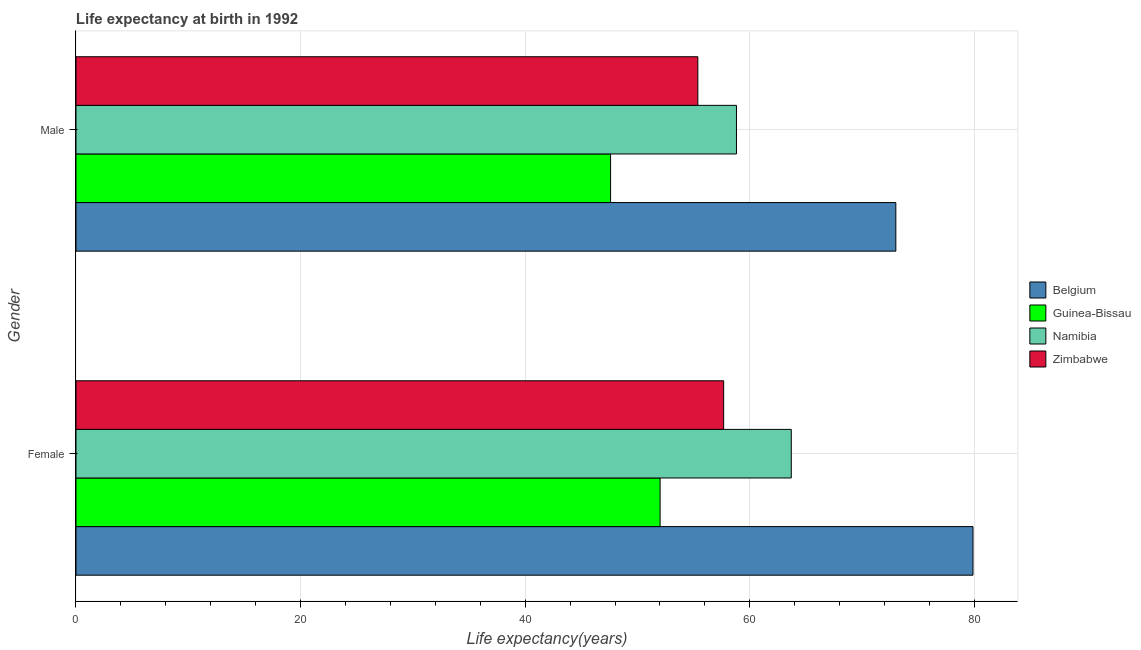How many groups of bars are there?
Your response must be concise. 2. Are the number of bars per tick equal to the number of legend labels?
Keep it short and to the point. Yes. Are the number of bars on each tick of the Y-axis equal?
Your response must be concise. Yes. How many bars are there on the 1st tick from the top?
Provide a succinct answer. 4. What is the life expectancy(female) in Belgium?
Give a very brief answer. 79.87. Across all countries, what is the maximum life expectancy(female)?
Your answer should be compact. 79.87. Across all countries, what is the minimum life expectancy(male)?
Offer a very short reply. 47.6. In which country was the life expectancy(female) minimum?
Ensure brevity in your answer.  Guinea-Bissau. What is the total life expectancy(female) in the graph?
Your answer should be very brief. 253.24. What is the difference between the life expectancy(female) in Belgium and that in Guinea-Bissau?
Your response must be concise. 27.86. What is the difference between the life expectancy(female) in Belgium and the life expectancy(male) in Zimbabwe?
Keep it short and to the point. 24.5. What is the average life expectancy(male) per country?
Provide a succinct answer. 58.7. What is the difference between the life expectancy(female) and life expectancy(male) in Namibia?
Give a very brief answer. 4.88. In how many countries, is the life expectancy(female) greater than 72 years?
Offer a very short reply. 1. What is the ratio of the life expectancy(male) in Guinea-Bissau to that in Belgium?
Provide a succinct answer. 0.65. What does the 3rd bar from the top in Male represents?
Your response must be concise. Guinea-Bissau. What does the 4th bar from the bottom in Male represents?
Your answer should be very brief. Zimbabwe. How many bars are there?
Provide a short and direct response. 8. What is the difference between two consecutive major ticks on the X-axis?
Ensure brevity in your answer.  20. How many legend labels are there?
Your answer should be compact. 4. What is the title of the graph?
Offer a terse response. Life expectancy at birth in 1992. What is the label or title of the X-axis?
Give a very brief answer. Life expectancy(years). What is the Life expectancy(years) in Belgium in Female?
Your answer should be compact. 79.87. What is the Life expectancy(years) of Guinea-Bissau in Female?
Your answer should be very brief. 52.01. What is the Life expectancy(years) in Namibia in Female?
Offer a terse response. 63.69. What is the Life expectancy(years) of Zimbabwe in Female?
Offer a very short reply. 57.67. What is the Life expectancy(years) in Guinea-Bissau in Male?
Offer a terse response. 47.6. What is the Life expectancy(years) in Namibia in Male?
Provide a short and direct response. 58.81. What is the Life expectancy(years) of Zimbabwe in Male?
Your answer should be compact. 55.37. Across all Gender, what is the maximum Life expectancy(years) in Belgium?
Provide a succinct answer. 79.87. Across all Gender, what is the maximum Life expectancy(years) in Guinea-Bissau?
Your answer should be compact. 52.01. Across all Gender, what is the maximum Life expectancy(years) in Namibia?
Provide a succinct answer. 63.69. Across all Gender, what is the maximum Life expectancy(years) in Zimbabwe?
Give a very brief answer. 57.67. Across all Gender, what is the minimum Life expectancy(years) in Guinea-Bissau?
Your answer should be compact. 47.6. Across all Gender, what is the minimum Life expectancy(years) of Namibia?
Provide a short and direct response. 58.81. Across all Gender, what is the minimum Life expectancy(years) in Zimbabwe?
Offer a very short reply. 55.37. What is the total Life expectancy(years) of Belgium in the graph?
Your answer should be compact. 152.87. What is the total Life expectancy(years) in Guinea-Bissau in the graph?
Provide a short and direct response. 99.61. What is the total Life expectancy(years) in Namibia in the graph?
Your response must be concise. 122.5. What is the total Life expectancy(years) of Zimbabwe in the graph?
Offer a very short reply. 113.04. What is the difference between the Life expectancy(years) of Belgium in Female and that in Male?
Provide a succinct answer. 6.87. What is the difference between the Life expectancy(years) of Guinea-Bissau in Female and that in Male?
Your answer should be compact. 4.41. What is the difference between the Life expectancy(years) of Namibia in Female and that in Male?
Ensure brevity in your answer.  4.88. What is the difference between the Life expectancy(years) of Zimbabwe in Female and that in Male?
Your answer should be very brief. 2.3. What is the difference between the Life expectancy(years) of Belgium in Female and the Life expectancy(years) of Guinea-Bissau in Male?
Provide a succinct answer. 32.27. What is the difference between the Life expectancy(years) of Belgium in Female and the Life expectancy(years) of Namibia in Male?
Ensure brevity in your answer.  21.06. What is the difference between the Life expectancy(years) in Belgium in Female and the Life expectancy(years) in Zimbabwe in Male?
Offer a terse response. 24.5. What is the difference between the Life expectancy(years) of Guinea-Bissau in Female and the Life expectancy(years) of Zimbabwe in Male?
Make the answer very short. -3.36. What is the difference between the Life expectancy(years) of Namibia in Female and the Life expectancy(years) of Zimbabwe in Male?
Make the answer very short. 8.32. What is the average Life expectancy(years) in Belgium per Gender?
Your response must be concise. 76.44. What is the average Life expectancy(years) in Guinea-Bissau per Gender?
Your answer should be very brief. 49.81. What is the average Life expectancy(years) of Namibia per Gender?
Keep it short and to the point. 61.25. What is the average Life expectancy(years) in Zimbabwe per Gender?
Make the answer very short. 56.52. What is the difference between the Life expectancy(years) of Belgium and Life expectancy(years) of Guinea-Bissau in Female?
Offer a very short reply. 27.86. What is the difference between the Life expectancy(years) in Belgium and Life expectancy(years) in Namibia in Female?
Provide a short and direct response. 16.18. What is the difference between the Life expectancy(years) of Belgium and Life expectancy(years) of Zimbabwe in Female?
Keep it short and to the point. 22.2. What is the difference between the Life expectancy(years) of Guinea-Bissau and Life expectancy(years) of Namibia in Female?
Offer a terse response. -11.68. What is the difference between the Life expectancy(years) in Guinea-Bissau and Life expectancy(years) in Zimbabwe in Female?
Your answer should be very brief. -5.66. What is the difference between the Life expectancy(years) of Namibia and Life expectancy(years) of Zimbabwe in Female?
Keep it short and to the point. 6.02. What is the difference between the Life expectancy(years) of Belgium and Life expectancy(years) of Guinea-Bissau in Male?
Your answer should be compact. 25.4. What is the difference between the Life expectancy(years) of Belgium and Life expectancy(years) of Namibia in Male?
Your answer should be very brief. 14.19. What is the difference between the Life expectancy(years) in Belgium and Life expectancy(years) in Zimbabwe in Male?
Give a very brief answer. 17.63. What is the difference between the Life expectancy(years) of Guinea-Bissau and Life expectancy(years) of Namibia in Male?
Make the answer very short. -11.21. What is the difference between the Life expectancy(years) in Guinea-Bissau and Life expectancy(years) in Zimbabwe in Male?
Your answer should be compact. -7.77. What is the difference between the Life expectancy(years) of Namibia and Life expectancy(years) of Zimbabwe in Male?
Offer a very short reply. 3.44. What is the ratio of the Life expectancy(years) of Belgium in Female to that in Male?
Make the answer very short. 1.09. What is the ratio of the Life expectancy(years) of Guinea-Bissau in Female to that in Male?
Give a very brief answer. 1.09. What is the ratio of the Life expectancy(years) of Namibia in Female to that in Male?
Give a very brief answer. 1.08. What is the ratio of the Life expectancy(years) in Zimbabwe in Female to that in Male?
Your response must be concise. 1.04. What is the difference between the highest and the second highest Life expectancy(years) of Belgium?
Offer a terse response. 6.87. What is the difference between the highest and the second highest Life expectancy(years) of Guinea-Bissau?
Give a very brief answer. 4.41. What is the difference between the highest and the second highest Life expectancy(years) in Namibia?
Provide a short and direct response. 4.88. What is the difference between the highest and the second highest Life expectancy(years) of Zimbabwe?
Give a very brief answer. 2.3. What is the difference between the highest and the lowest Life expectancy(years) of Belgium?
Your answer should be very brief. 6.87. What is the difference between the highest and the lowest Life expectancy(years) in Guinea-Bissau?
Keep it short and to the point. 4.41. What is the difference between the highest and the lowest Life expectancy(years) of Namibia?
Make the answer very short. 4.88. What is the difference between the highest and the lowest Life expectancy(years) in Zimbabwe?
Give a very brief answer. 2.3. 